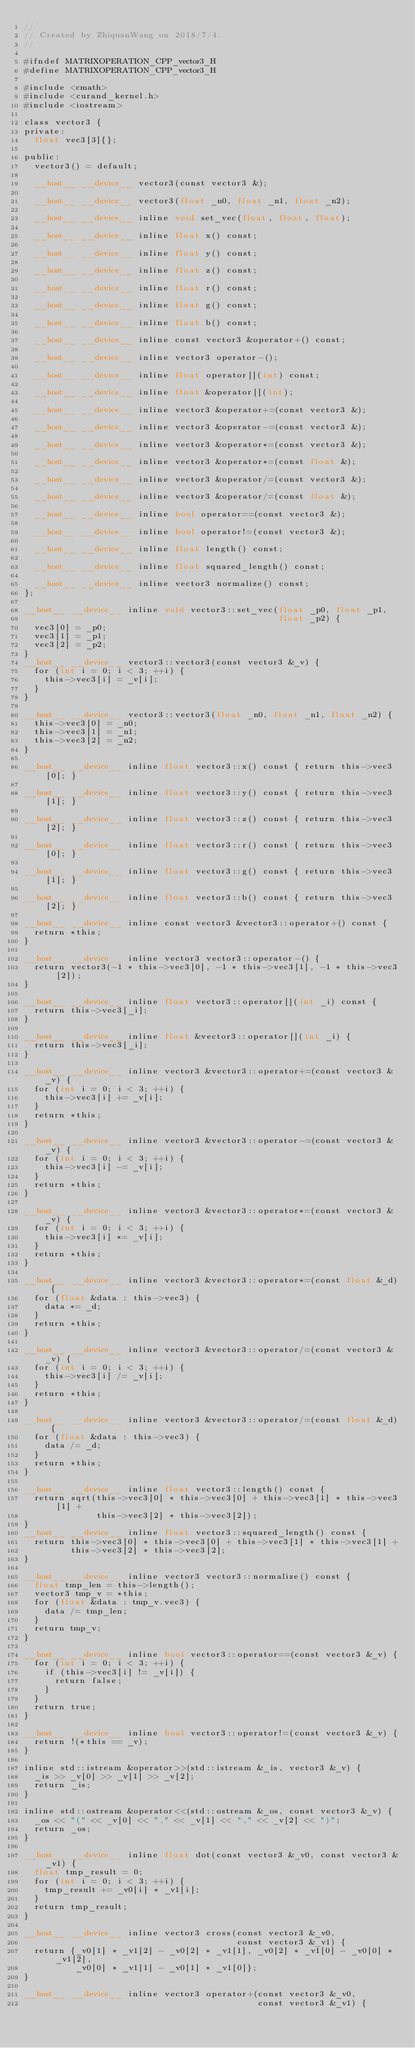<code> <loc_0><loc_0><loc_500><loc_500><_Cuda_>//
// Created by ZhiquanWang on 2018/7/4.
//

#ifndef MATRIXOPERATION_CPP_vector3_H
#define MATRIXOPERATION_CPP_vector3_H

#include <cmath>
#include <curand_kernel.h>
#include <iostream>

class vector3 {
private:
  float vec3[3]{};

public:
  vector3() = default;

  __host__ __device__ vector3(const vector3 &);

  __host__ __device__ vector3(float _n0, float _n1, float _n2);

  __host__ __device__ inline void set_vec(float, float, float);

  __host__ __device__ inline float x() const;

  __host__ __device__ inline float y() const;

  __host__ __device__ inline float z() const;

  __host__ __device__ inline float r() const;

  __host__ __device__ inline float g() const;

  __host__ __device__ inline float b() const;

  __host__ __device__ inline const vector3 &operator+() const;

  __host__ __device__ inline vector3 operator-();

  __host__ __device__ inline float operator[](int) const;

  __host__ __device__ inline float &operator[](int);

  __host__ __device__ inline vector3 &operator+=(const vector3 &);

  __host__ __device__ inline vector3 &operator-=(const vector3 &);

  __host__ __device__ inline vector3 &operator*=(const vector3 &);

  __host__ __device__ inline vector3 &operator*=(const float &);

  __host__ __device__ inline vector3 &operator/=(const vector3 &);

  __host__ __device__ inline vector3 &operator/=(const float &);

  __host__ __device__ inline bool operator==(const vector3 &);

  __host__ __device__ inline bool operator!=(const vector3 &);

  __host__ __device__ inline float length() const;

  __host__ __device__ inline float squared_length() const;

  __host__ __device__ inline vector3 normalize() const;
};

__host__ __device__ inline void vector3::set_vec(float _p0, float _p1,
                                                 float _p2) {
  vec3[0] = _p0;
  vec3[1] = _p1;
  vec3[2] = _p2;
}
__host__ __device__ vector3::vector3(const vector3 &_v) {
  for (int i = 0; i < 3; ++i) {
    this->vec3[i] = _v[i];
  }
}

__host__ __device__ vector3::vector3(float _n0, float _n1, float _n2) {
  this->vec3[0] = _n0;
  this->vec3[1] = _n1;
  this->vec3[2] = _n2;
}

__host__ __device__ inline float vector3::x() const { return this->vec3[0]; }

__host__ __device__ inline float vector3::y() const { return this->vec3[1]; }

__host__ __device__ inline float vector3::z() const { return this->vec3[2]; }

__host__ __device__ inline float vector3::r() const { return this->vec3[0]; }

__host__ __device__ inline float vector3::g() const { return this->vec3[1]; }

__host__ __device__ inline float vector3::b() const { return this->vec3[2]; }

__host__ __device__ inline const vector3 &vector3::operator+() const {
  return *this;
}

__host__ __device__ inline vector3 vector3::operator-() {
  return vector3(-1 * this->vec3[0], -1 * this->vec3[1], -1 * this->vec3[2]);
}

__host__ __device__ inline float vector3::operator[](int _i) const {
  return this->vec3[_i];
}

__host__ __device__ inline float &vector3::operator[](int _i) {
  return this->vec3[_i];
}

__host__ __device__ inline vector3 &vector3::operator+=(const vector3 &_v) {
  for (int i = 0; i < 3; ++i) {
    this->vec3[i] += _v[i];
  }
  return *this;
}

__host__ __device__ inline vector3 &vector3::operator-=(const vector3 &_v) {
  for (int i = 0; i < 3; ++i) {
    this->vec3[i] -= _v[i];
  }
  return *this;
}

__host__ __device__ inline vector3 &vector3::operator*=(const vector3 &_v) {
  for (int i = 0; i < 3; ++i) {
    this->vec3[i] *= _v[i];
  }
  return *this;
}

__host__ __device__ inline vector3 &vector3::operator*=(const float &_d) {
  for (float &data : this->vec3) {
    data *= _d;
  }
  return *this;
}

__host__ __device__ inline vector3 &vector3::operator/=(const vector3 &_v) {
  for (int i = 0; i < 3; ++i) {
    this->vec3[i] /= _v[i];
  }
  return *this;
}

__host__ __device__ inline vector3 &vector3::operator/=(const float &_d) {
  for (float &data : this->vec3) {
    data /= _d;
  }
  return *this;
}

__host__ __device__ inline float vector3::length() const {
  return sqrt(this->vec3[0] * this->vec3[0] + this->vec3[1] * this->vec3[1] +
              this->vec3[2] * this->vec3[2]);
}
__host__ __device__ inline float vector3::squared_length() const {
  return this->vec3[0] * this->vec3[0] + this->vec3[1] * this->vec3[1] +
         this->vec3[2] * this->vec3[2];
}

__host__ __device__ inline vector3 vector3::normalize() const {
  float tmp_len = this->length();
  vector3 tmp_v = *this;
  for (float &data : tmp_v.vec3) {
    data /= tmp_len;
  }
  return tmp_v;
}

__host__ __device__ inline bool vector3::operator==(const vector3 &_v) {
  for (int i = 0; i < 3; ++i) {
    if (this->vec3[i] != _v[i]) {
      return false;
    }
  }
  return true;
}

__host__ __device__ inline bool vector3::operator!=(const vector3 &_v) {
  return !(*this == _v);
}

inline std::istream &operator>>(std::istream &_is, vector3 &_v) {
  _is >> _v[0] >> _v[1] >> _v[2];
  return _is;
}

inline std::ostream &operator<<(std::ostream &_os, const vector3 &_v) {
  _os << "(" << _v[0] << "," << _v[1] << "," << _v[2] << ")";
  return _os;
}

__host__ __device__ inline float dot(const vector3 &_v0, const vector3 &_v1) {
  float tmp_result = 0;
  for (int i = 0; i < 3; ++i) {
    tmp_result += _v0[i] * _v1[i];
  }
  return tmp_result;
}

__host__ __device__ inline vector3 cross(const vector3 &_v0,
                                         const vector3 &_v1) {
  return {_v0[1] * _v1[2] - _v0[2] * _v1[1], _v0[2] * _v1[0] - _v0[0] * _v1[2],
          _v0[0] * _v1[1] - _v0[1] * _v1[0]};
}

__host__ __device__ inline vector3 operator+(const vector3 &_v0,
                                             const vector3 &_v1) {</code> 